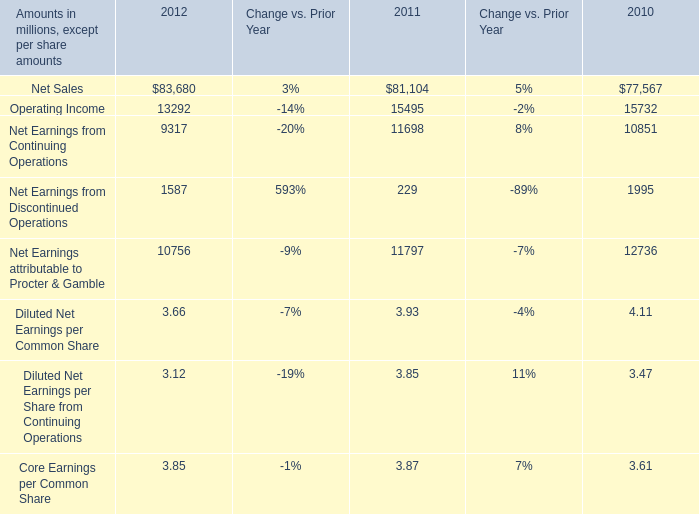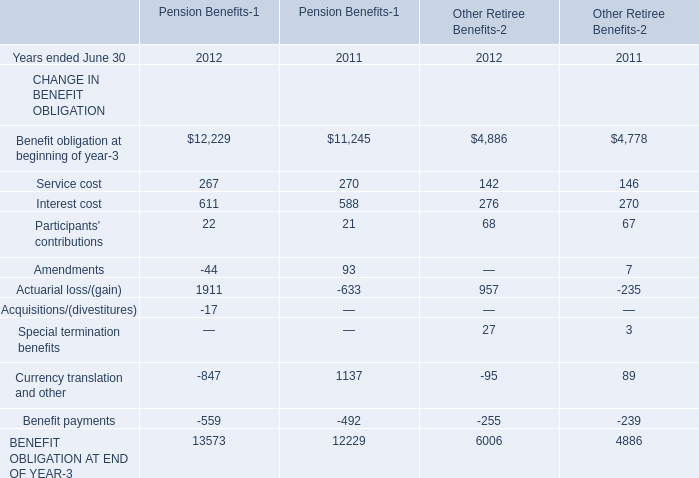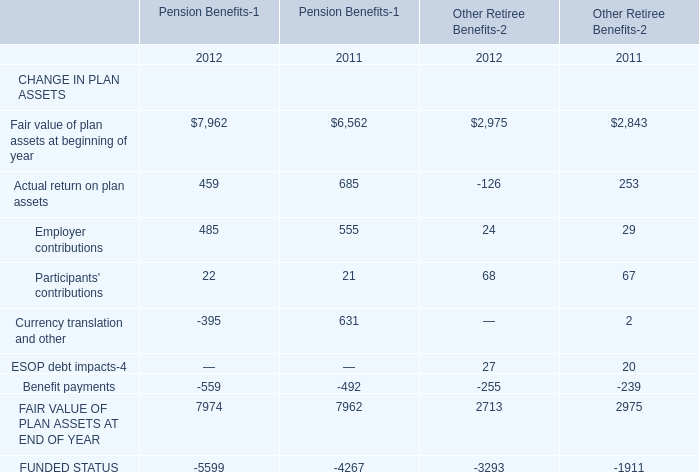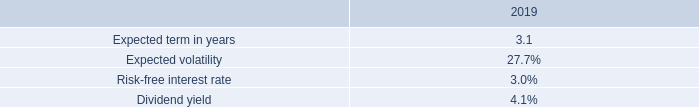What was the total amount of Pension Benefits-1 greater than 100 in 2012 for CHANGE IN PLAN ASSETS? 
Computations: ((7962 + 459) + 485)
Answer: 8906.0. 